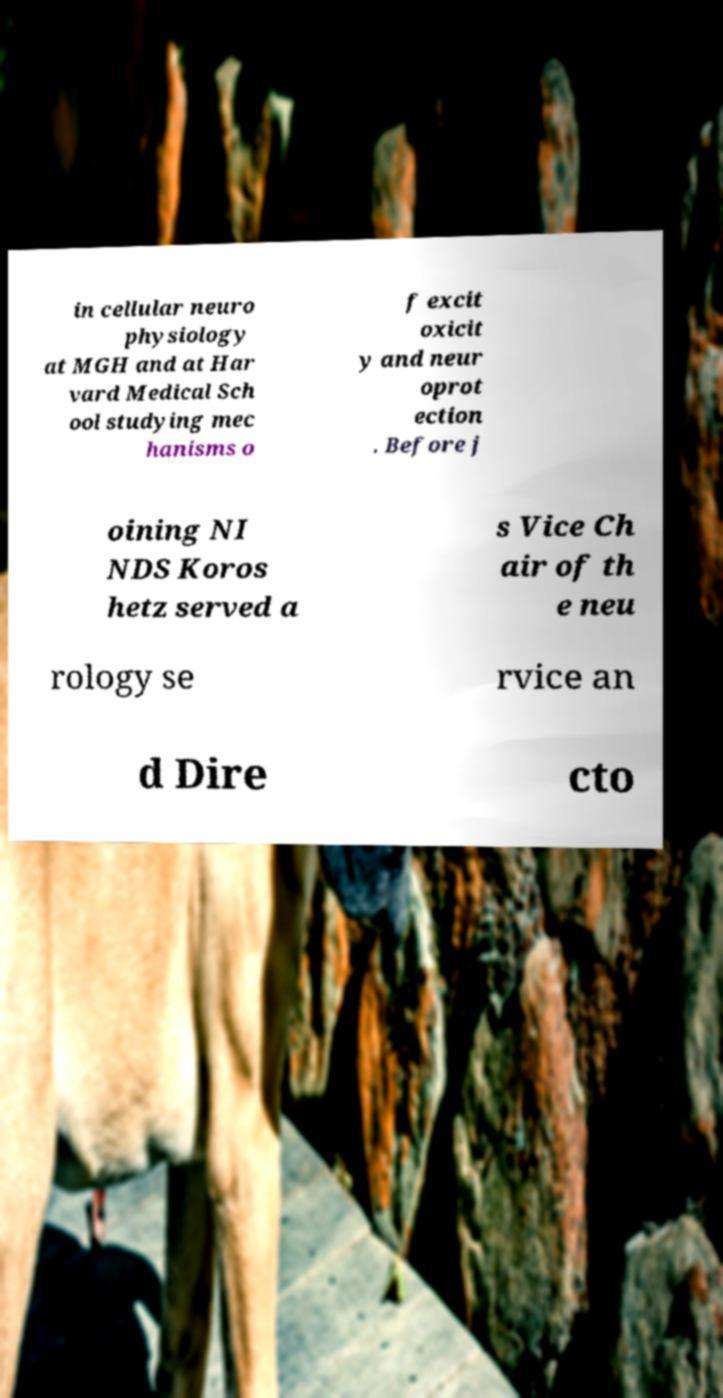For documentation purposes, I need the text within this image transcribed. Could you provide that? in cellular neuro physiology at MGH and at Har vard Medical Sch ool studying mec hanisms o f excit oxicit y and neur oprot ection . Before j oining NI NDS Koros hetz served a s Vice Ch air of th e neu rology se rvice an d Dire cto 